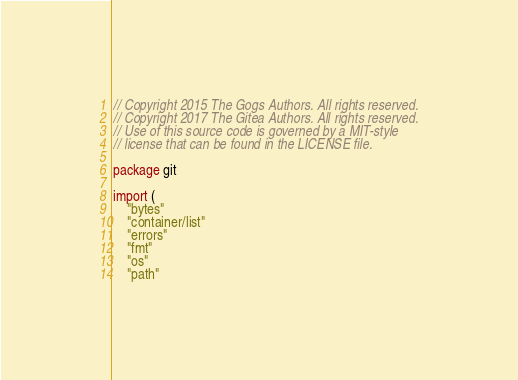<code> <loc_0><loc_0><loc_500><loc_500><_Go_>// Copyright 2015 The Gogs Authors. All rights reserved.
// Copyright 2017 The Gitea Authors. All rights reserved.
// Use of this source code is governed by a MIT-style
// license that can be found in the LICENSE file.

package git

import (
	"bytes"
	"container/list"
	"errors"
	"fmt"
	"os"
	"path"</code> 